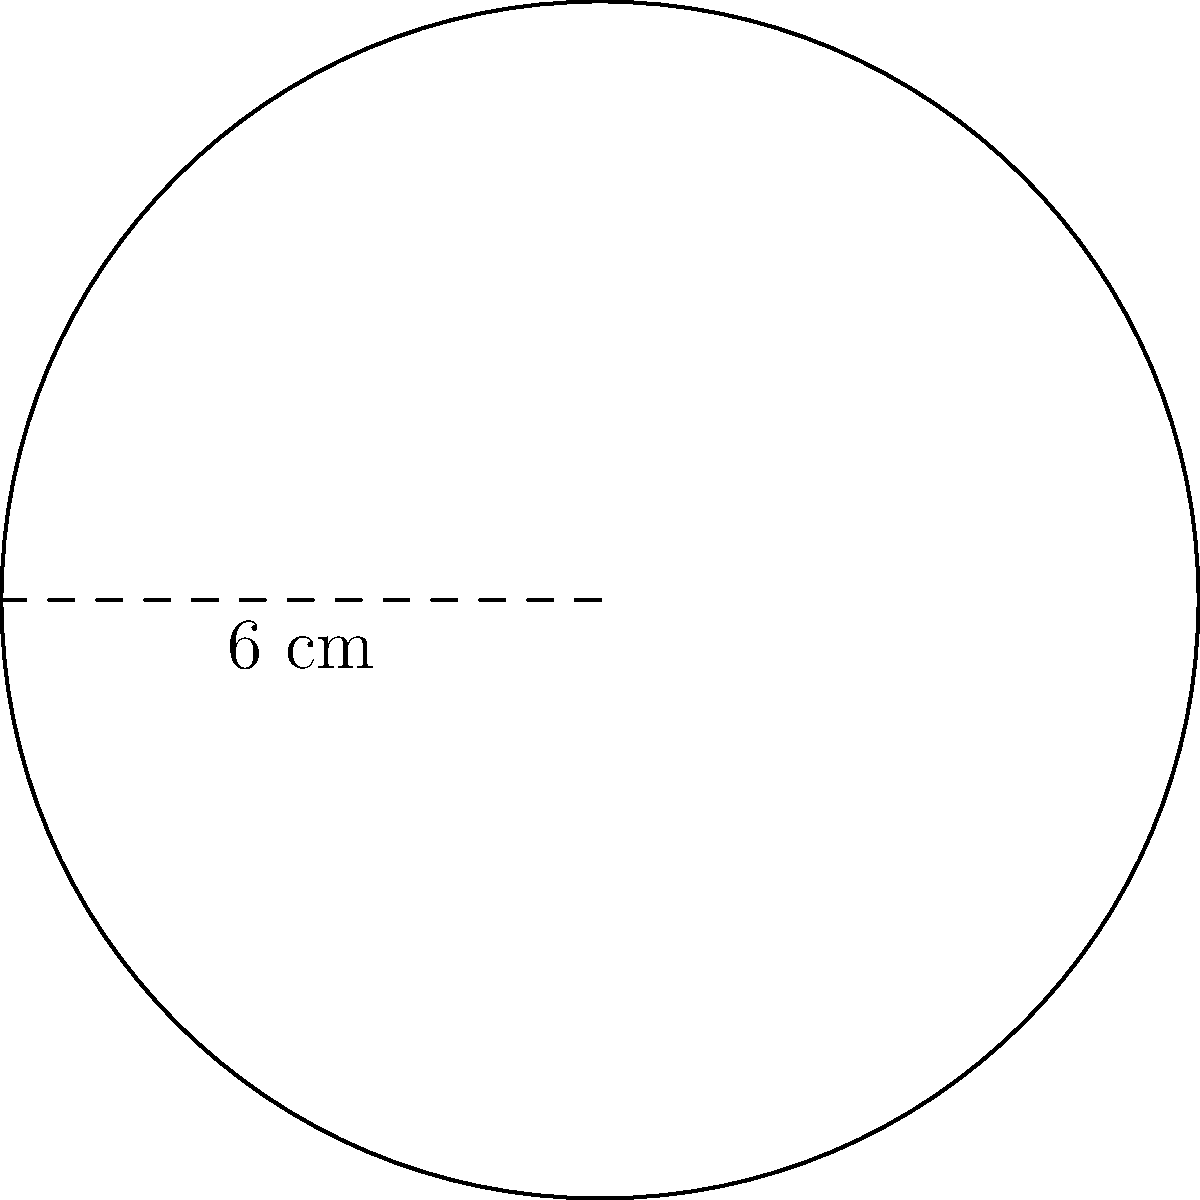Your new smart speaker has a circular base. The diameter of the base is 6 cm. What is the area of the speaker's base in square centimeters? Round your answer to the nearest tenth. Let's solve this step-by-step:

1) We're given the diameter of the circular base, which is 6 cm.

2) To find the area, we need the radius. The radius is half the diameter:
   $r = 6 \div 2 = 3$ cm

3) The formula for the area of a circle is:
   $A = \pi r^2$

4) Let's substitute our radius value:
   $A = \pi (3)^2$

5) Simplify:
   $A = \pi (9)$
   $A = 9\pi$

6) Using 3.14159 for $\pi$:
   $A = 9 \times 3.14159 = 28.27431$ sq cm

7) Rounding to the nearest tenth:
   $A \approx 28.3$ sq cm
Answer: 28.3 sq cm 